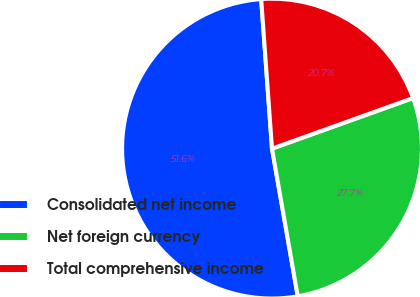Convert chart to OTSL. <chart><loc_0><loc_0><loc_500><loc_500><pie_chart><fcel>Consolidated net income<fcel>Net foreign currency<fcel>Total comprehensive income<nl><fcel>51.6%<fcel>27.73%<fcel>20.67%<nl></chart> 